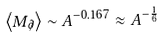Convert formula to latex. <formula><loc_0><loc_0><loc_500><loc_500>\left < M _ { \not \partial } \right > \sim A ^ { - 0 . 1 6 7 } \approx A ^ { - \frac { 1 } { 6 } }</formula> 